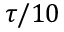<formula> <loc_0><loc_0><loc_500><loc_500>\tau / 1 0</formula> 